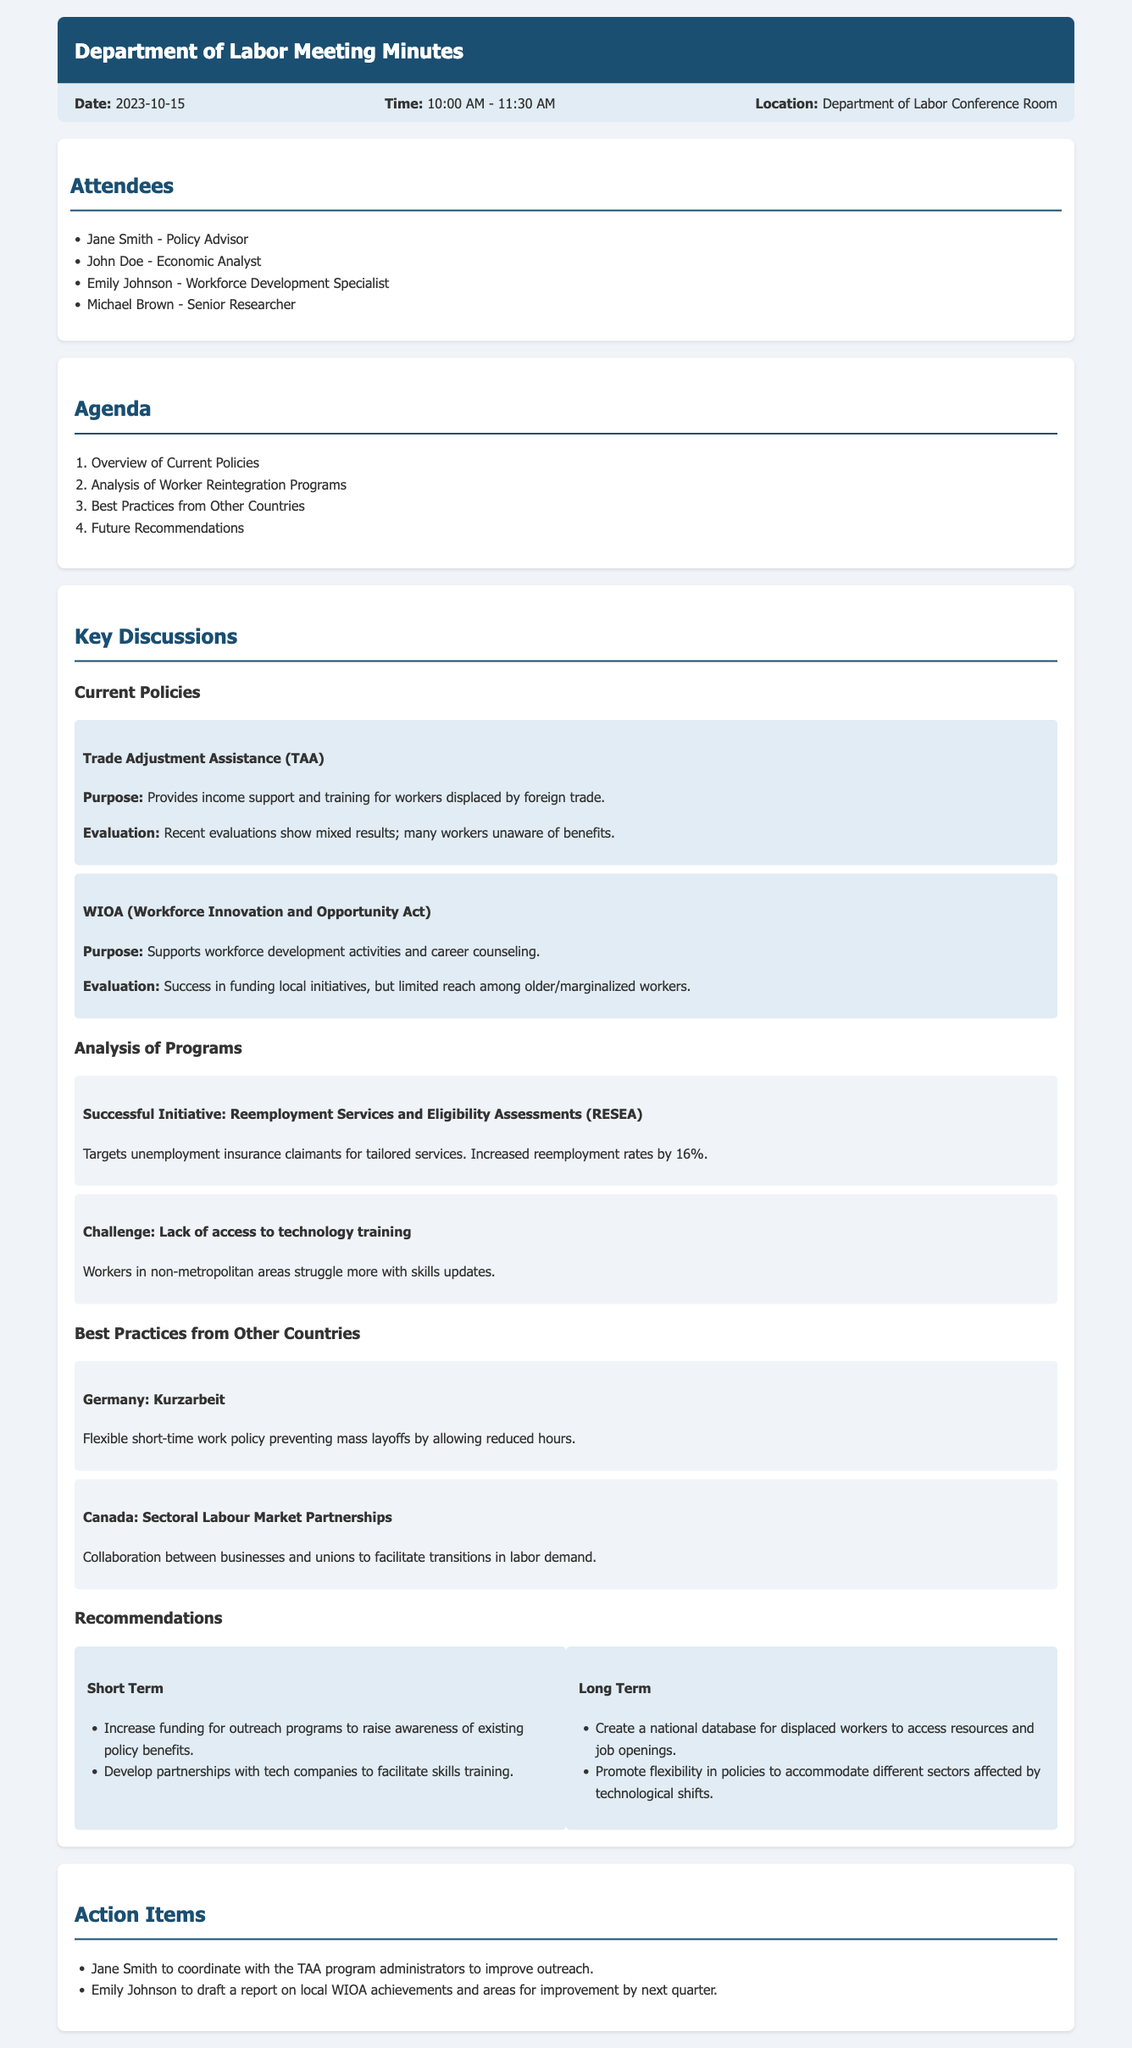What was the date of the meeting? The date of the meeting is specified in the meta-info section of the document.
Answer: 2023-10-15 Who coordinated the outreach for the TAA program? The action item section specifies who is responsible for coordinating outreach activities.
Answer: Jane Smith What percentage did the Reemployment Services and Eligibility Assessments increase reemployment rates by? The evaluation of the RESEA program in the document indicates its reemployment rate impact.
Answer: 16% What primary challenge is mentioned regarding technology training? A challenge section outlines specific issues faced by workers related to skills training.
Answer: Lack of access to technology training Which policy provides income support and training for workers displaced by foreign trade? The current policies section highlights different policies and their purposes.
Answer: Trade Adjustment Assistance (TAA) What is one of the short-term recommendations? The recommendations section provides a list of actions to take in the near future.
Answer: Increase funding for outreach programs to raise awareness of existing policy benefits What best practice from Germany is discussed? The best practices discussed in the document provide examples of effective methods from other countries.
Answer: Kurzarbeit How long did the meeting last? The time range provided in the meta-info section indicates the duration of the meeting.
Answer: 1 hour 30 minutes 